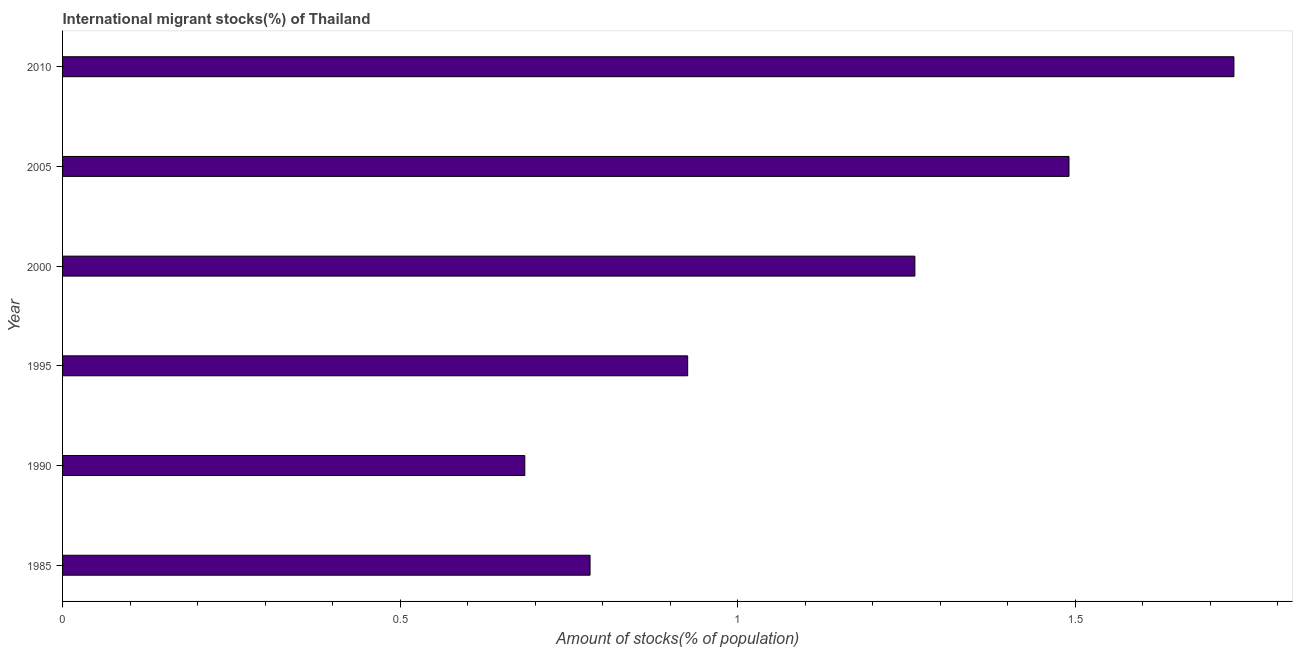Does the graph contain grids?
Offer a terse response. No. What is the title of the graph?
Provide a short and direct response. International migrant stocks(%) of Thailand. What is the label or title of the X-axis?
Provide a succinct answer. Amount of stocks(% of population). What is the label or title of the Y-axis?
Provide a short and direct response. Year. What is the number of international migrant stocks in 1985?
Offer a very short reply. 0.78. Across all years, what is the maximum number of international migrant stocks?
Offer a terse response. 1.74. Across all years, what is the minimum number of international migrant stocks?
Ensure brevity in your answer.  0.68. In which year was the number of international migrant stocks minimum?
Give a very brief answer. 1990. What is the sum of the number of international migrant stocks?
Keep it short and to the point. 6.88. What is the difference between the number of international migrant stocks in 1995 and 2005?
Make the answer very short. -0.56. What is the average number of international migrant stocks per year?
Your response must be concise. 1.15. What is the median number of international migrant stocks?
Offer a very short reply. 1.09. In how many years, is the number of international migrant stocks greater than 1.5 %?
Offer a terse response. 1. Do a majority of the years between 1990 and 2010 (inclusive) have number of international migrant stocks greater than 0.6 %?
Your answer should be compact. Yes. What is the ratio of the number of international migrant stocks in 1985 to that in 2005?
Give a very brief answer. 0.52. Is the difference between the number of international migrant stocks in 1985 and 2010 greater than the difference between any two years?
Provide a short and direct response. No. What is the difference between the highest and the second highest number of international migrant stocks?
Provide a succinct answer. 0.24. In how many years, is the number of international migrant stocks greater than the average number of international migrant stocks taken over all years?
Offer a terse response. 3. What is the difference between two consecutive major ticks on the X-axis?
Offer a very short reply. 0.5. Are the values on the major ticks of X-axis written in scientific E-notation?
Your response must be concise. No. What is the Amount of stocks(% of population) in 1985?
Your answer should be very brief. 0.78. What is the Amount of stocks(% of population) of 1990?
Offer a terse response. 0.68. What is the Amount of stocks(% of population) in 1995?
Provide a short and direct response. 0.93. What is the Amount of stocks(% of population) in 2000?
Offer a very short reply. 1.26. What is the Amount of stocks(% of population) in 2005?
Offer a terse response. 1.49. What is the Amount of stocks(% of population) of 2010?
Make the answer very short. 1.74. What is the difference between the Amount of stocks(% of population) in 1985 and 1990?
Provide a short and direct response. 0.1. What is the difference between the Amount of stocks(% of population) in 1985 and 1995?
Provide a succinct answer. -0.14. What is the difference between the Amount of stocks(% of population) in 1985 and 2000?
Offer a very short reply. -0.48. What is the difference between the Amount of stocks(% of population) in 1985 and 2005?
Make the answer very short. -0.71. What is the difference between the Amount of stocks(% of population) in 1985 and 2010?
Make the answer very short. -0.95. What is the difference between the Amount of stocks(% of population) in 1990 and 1995?
Make the answer very short. -0.24. What is the difference between the Amount of stocks(% of population) in 1990 and 2000?
Make the answer very short. -0.58. What is the difference between the Amount of stocks(% of population) in 1990 and 2005?
Keep it short and to the point. -0.81. What is the difference between the Amount of stocks(% of population) in 1990 and 2010?
Give a very brief answer. -1.05. What is the difference between the Amount of stocks(% of population) in 1995 and 2000?
Ensure brevity in your answer.  -0.34. What is the difference between the Amount of stocks(% of population) in 1995 and 2005?
Your answer should be compact. -0.56. What is the difference between the Amount of stocks(% of population) in 1995 and 2010?
Offer a terse response. -0.81. What is the difference between the Amount of stocks(% of population) in 2000 and 2005?
Offer a terse response. -0.23. What is the difference between the Amount of stocks(% of population) in 2000 and 2010?
Keep it short and to the point. -0.47. What is the difference between the Amount of stocks(% of population) in 2005 and 2010?
Provide a short and direct response. -0.24. What is the ratio of the Amount of stocks(% of population) in 1985 to that in 1990?
Offer a very short reply. 1.14. What is the ratio of the Amount of stocks(% of population) in 1985 to that in 1995?
Keep it short and to the point. 0.84. What is the ratio of the Amount of stocks(% of population) in 1985 to that in 2000?
Keep it short and to the point. 0.62. What is the ratio of the Amount of stocks(% of population) in 1985 to that in 2005?
Make the answer very short. 0.52. What is the ratio of the Amount of stocks(% of population) in 1985 to that in 2010?
Make the answer very short. 0.45. What is the ratio of the Amount of stocks(% of population) in 1990 to that in 1995?
Make the answer very short. 0.74. What is the ratio of the Amount of stocks(% of population) in 1990 to that in 2000?
Your answer should be compact. 0.54. What is the ratio of the Amount of stocks(% of population) in 1990 to that in 2005?
Give a very brief answer. 0.46. What is the ratio of the Amount of stocks(% of population) in 1990 to that in 2010?
Make the answer very short. 0.4. What is the ratio of the Amount of stocks(% of population) in 1995 to that in 2000?
Keep it short and to the point. 0.73. What is the ratio of the Amount of stocks(% of population) in 1995 to that in 2005?
Offer a terse response. 0.62. What is the ratio of the Amount of stocks(% of population) in 1995 to that in 2010?
Your response must be concise. 0.53. What is the ratio of the Amount of stocks(% of population) in 2000 to that in 2005?
Your answer should be compact. 0.85. What is the ratio of the Amount of stocks(% of population) in 2000 to that in 2010?
Ensure brevity in your answer.  0.73. What is the ratio of the Amount of stocks(% of population) in 2005 to that in 2010?
Keep it short and to the point. 0.86. 